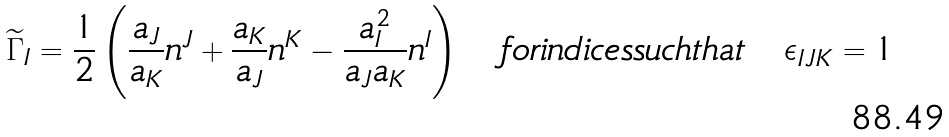Convert formula to latex. <formula><loc_0><loc_0><loc_500><loc_500>\widetilde { \Gamma } _ { I } = \frac { 1 } { 2 } \left ( \frac { a _ { J } } { a _ { K } } n ^ { J } + \frac { a _ { K } } { a _ { J } } n ^ { K } - \frac { a _ { I } ^ { 2 } } { a _ { J } a _ { K } } n ^ { I } \right ) \quad f o r i n d i c e s s u c h t h a t \quad \epsilon _ { I J K } = 1</formula> 